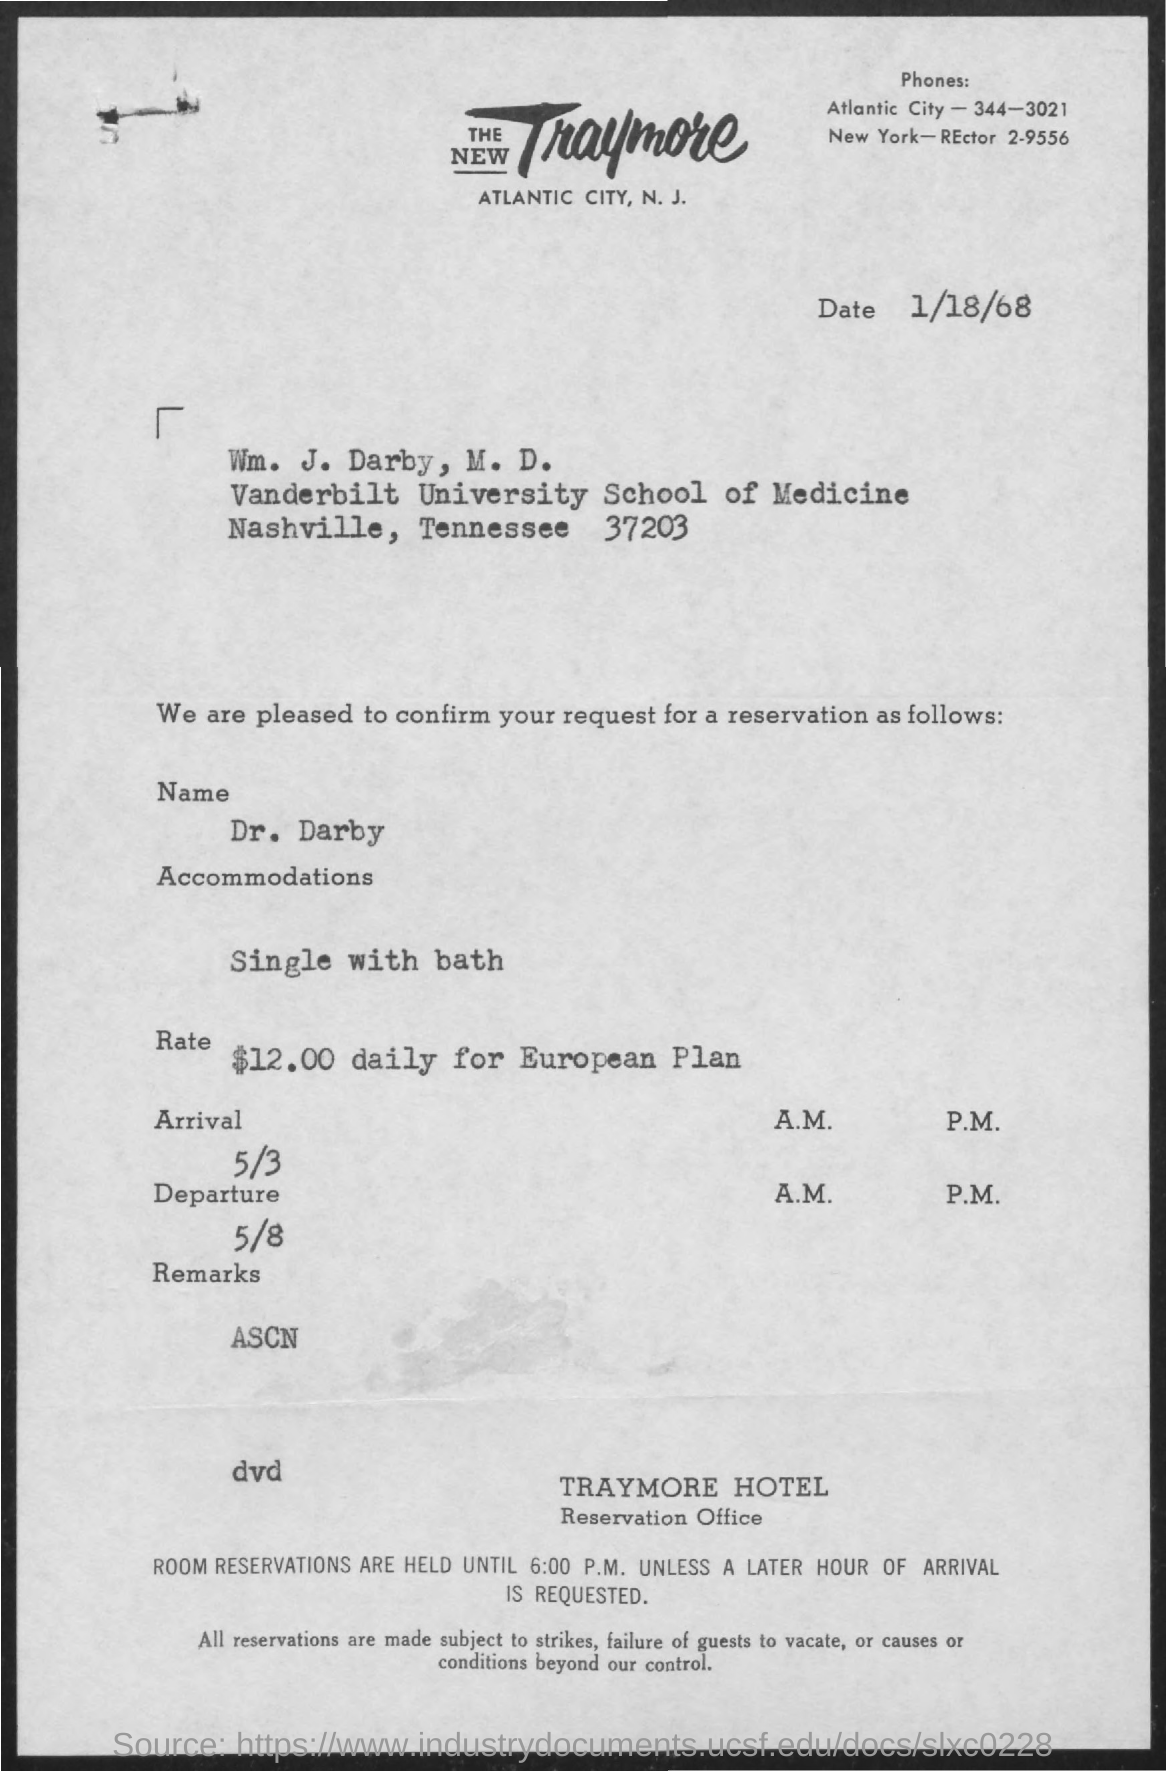Mention a couple of crucial points in this snapshot. The phone number of Atlantic City is 344-3021. Dr. Darby booked a single room with a bath. The person who reserved the room is Dr. Darby. The date mentioned at the top of the document is January 18th, 1968. 